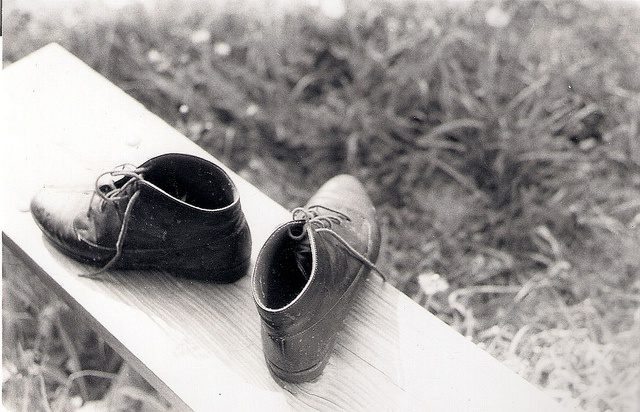Describe the objects in this image and their specific colors. I can see a bench in gray, white, black, and darkgray tones in this image. 